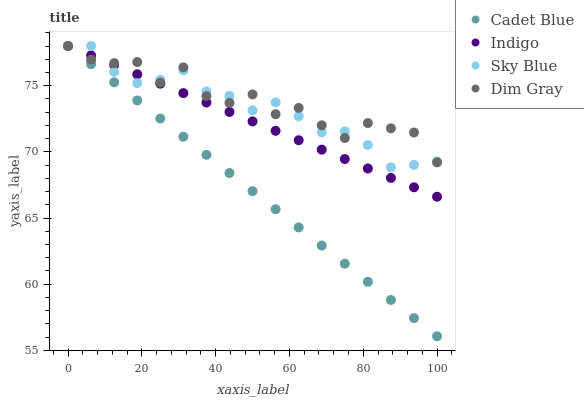Does Cadet Blue have the minimum area under the curve?
Answer yes or no. Yes. Does Dim Gray have the maximum area under the curve?
Answer yes or no. Yes. Does Dim Gray have the minimum area under the curve?
Answer yes or no. No. Does Cadet Blue have the maximum area under the curve?
Answer yes or no. No. Is Indigo the smoothest?
Answer yes or no. Yes. Is Dim Gray the roughest?
Answer yes or no. Yes. Is Cadet Blue the smoothest?
Answer yes or no. No. Is Cadet Blue the roughest?
Answer yes or no. No. Does Cadet Blue have the lowest value?
Answer yes or no. Yes. Does Dim Gray have the lowest value?
Answer yes or no. No. Does Indigo have the highest value?
Answer yes or no. Yes. Does Indigo intersect Dim Gray?
Answer yes or no. Yes. Is Indigo less than Dim Gray?
Answer yes or no. No. Is Indigo greater than Dim Gray?
Answer yes or no. No. 